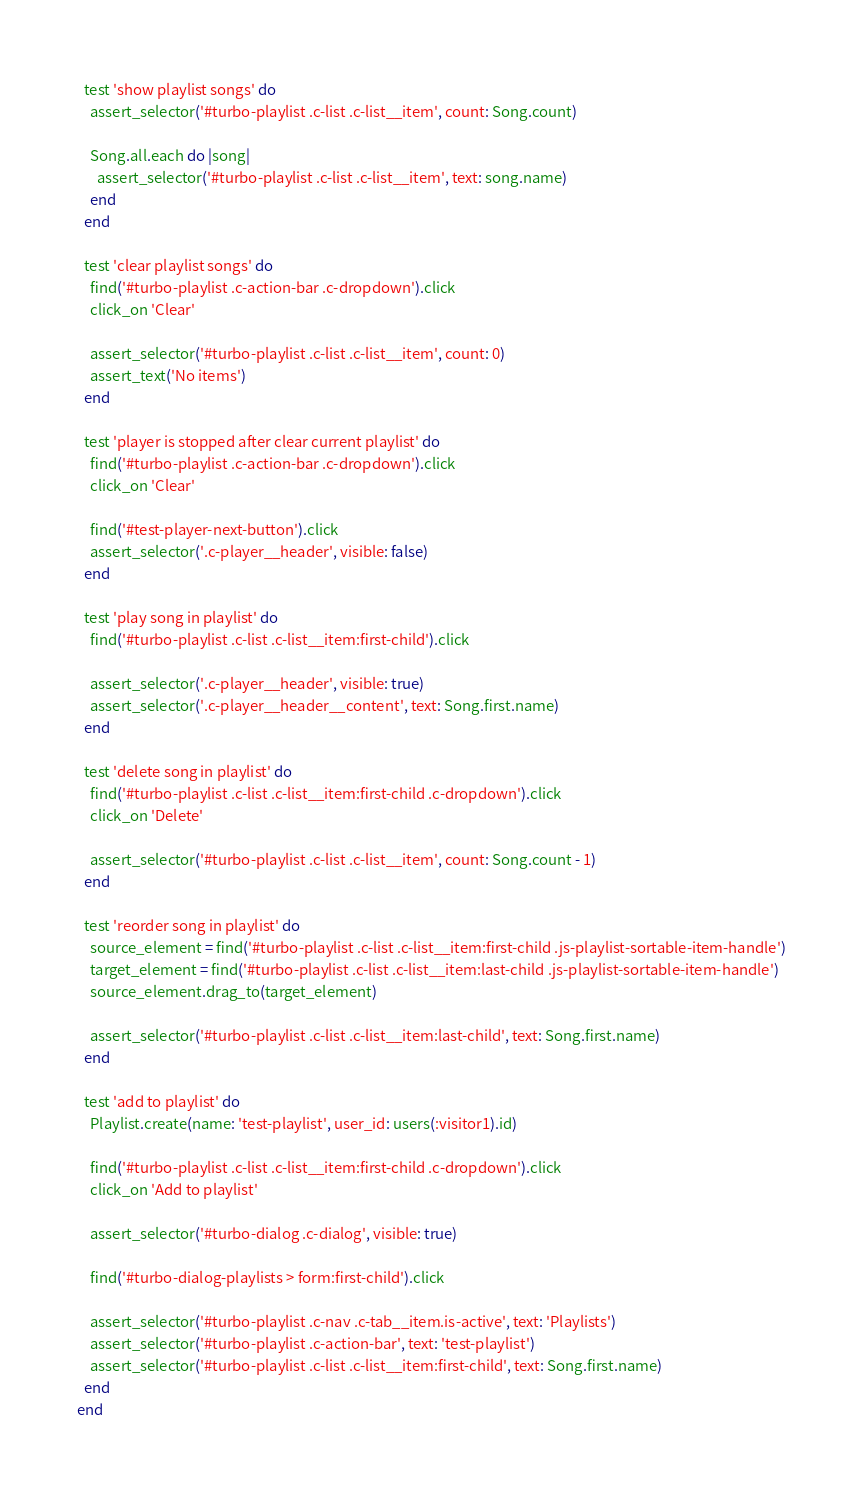Convert code to text. <code><loc_0><loc_0><loc_500><loc_500><_Ruby_>  test 'show playlist songs' do
    assert_selector('#turbo-playlist .c-list .c-list__item', count: Song.count)

    Song.all.each do |song|
      assert_selector('#turbo-playlist .c-list .c-list__item', text: song.name)
    end
  end

  test 'clear playlist songs' do
    find('#turbo-playlist .c-action-bar .c-dropdown').click
    click_on 'Clear'

    assert_selector('#turbo-playlist .c-list .c-list__item', count: 0)
    assert_text('No items')
  end

  test 'player is stopped after clear current playlist' do
    find('#turbo-playlist .c-action-bar .c-dropdown').click
    click_on 'Clear'

    find('#test-player-next-button').click
    assert_selector('.c-player__header', visible: false)
  end

  test 'play song in playlist' do
    find('#turbo-playlist .c-list .c-list__item:first-child').click

    assert_selector('.c-player__header', visible: true)
    assert_selector('.c-player__header__content', text: Song.first.name)
  end

  test 'delete song in playlist' do
    find('#turbo-playlist .c-list .c-list__item:first-child .c-dropdown').click
    click_on 'Delete'

    assert_selector('#turbo-playlist .c-list .c-list__item', count: Song.count - 1)
  end

  test 'reorder song in playlist' do
    source_element = find('#turbo-playlist .c-list .c-list__item:first-child .js-playlist-sortable-item-handle')
    target_element = find('#turbo-playlist .c-list .c-list__item:last-child .js-playlist-sortable-item-handle')
    source_element.drag_to(target_element)

    assert_selector('#turbo-playlist .c-list .c-list__item:last-child', text: Song.first.name)
  end

  test 'add to playlist' do
    Playlist.create(name: 'test-playlist', user_id: users(:visitor1).id)

    find('#turbo-playlist .c-list .c-list__item:first-child .c-dropdown').click
    click_on 'Add to playlist'

    assert_selector('#turbo-dialog .c-dialog', visible: true)

    find('#turbo-dialog-playlists > form:first-child').click

    assert_selector('#turbo-playlist .c-nav .c-tab__item.is-active', text: 'Playlists')
    assert_selector('#turbo-playlist .c-action-bar', text: 'test-playlist')
    assert_selector('#turbo-playlist .c-list .c-list__item:first-child', text: Song.first.name)
  end
end
</code> 